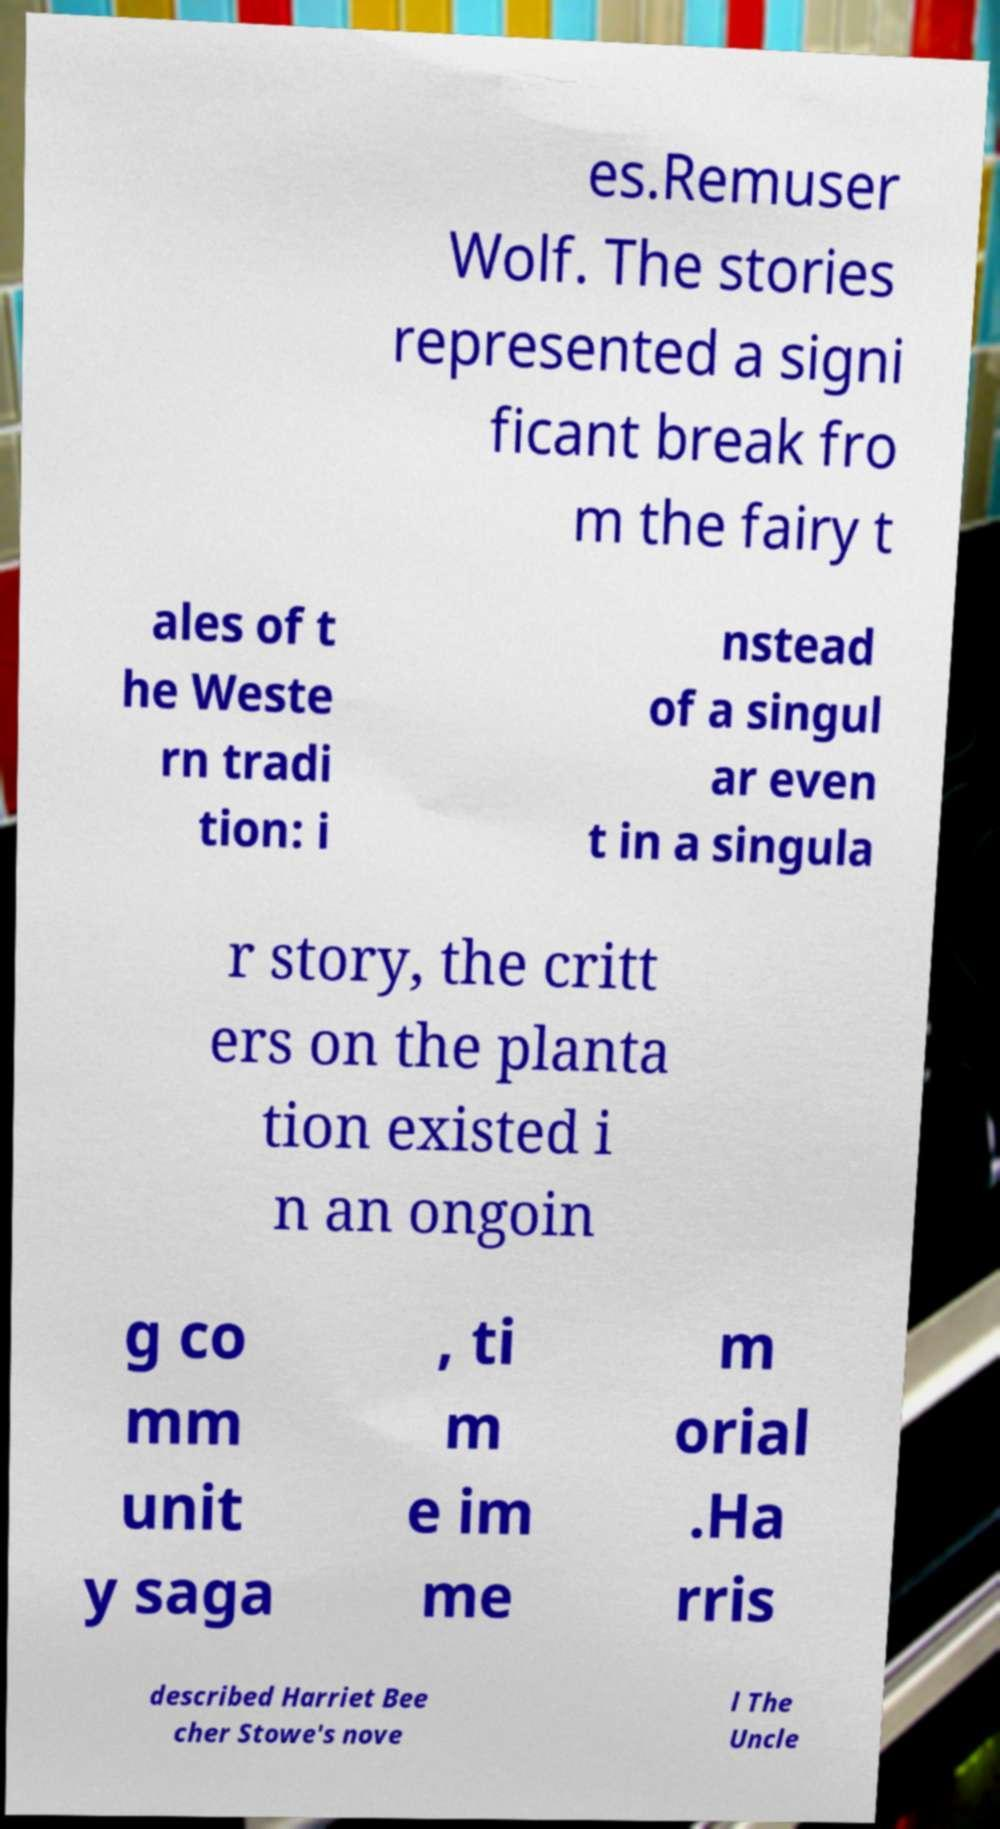Can you read and provide the text displayed in the image?This photo seems to have some interesting text. Can you extract and type it out for me? es.Remuser Wolf. The stories represented a signi ficant break fro m the fairy t ales of t he Weste rn tradi tion: i nstead of a singul ar even t in a singula r story, the critt ers on the planta tion existed i n an ongoin g co mm unit y saga , ti m e im me m orial .Ha rris described Harriet Bee cher Stowe's nove l The Uncle 